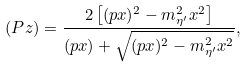<formula> <loc_0><loc_0><loc_500><loc_500>( P z ) = \frac { 2 \left [ ( p x ) ^ { 2 } - m _ { \eta ^ { \prime } } ^ { 2 } x ^ { 2 } \right ] } { ( p x ) + \sqrt { ( p x ) ^ { 2 } - m _ { \eta ^ { \prime } } ^ { 2 } x ^ { 2 } } } ,</formula> 